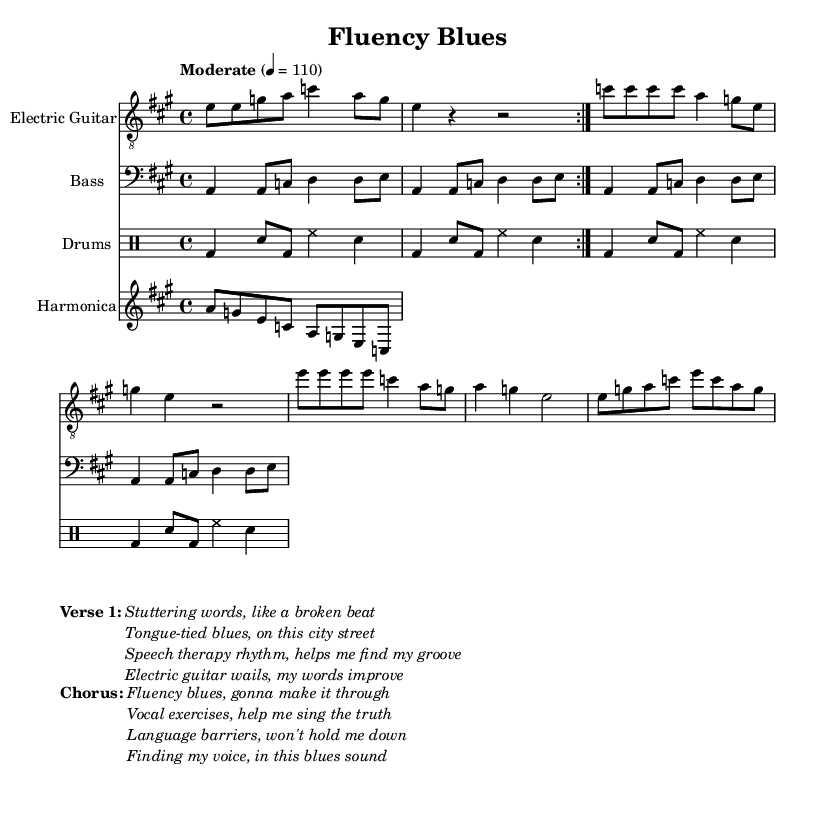What is the key signature of this music? The key signature is A major, which has three sharps (F#, C#, and G#). This can be identified in the left corner of the staff where the sharp symbols are placed.
Answer: A major What is the time signature of this music? The time signature is 4/4, which is indicated by the two numbers at the beginning of the piece, telling us there are four beats per measure.
Answer: 4/4 What is the tempo marking of this piece? The tempo is marked as "Moderate" with a metronome marking of 110 beats per minute. This can be seen at the start where the tempo is indicated.
Answer: Moderate, 110 How many repetitions are there in the intro section? The intro section is marked to repeat twice, as indicated by the "repeat volta 2" notation before the introductory riff.
Answer: 2 What instrument plays the harmonica solo? The score clearly shows that the harmonica solo is written for the "Harmonica" staff, distinguishing it from other instruments in the ensemble.
Answer: Harmonica What are the main themes expressed in the verse section? The verse discusses overcoming speech difficulties and improving fluency through rhythm and music, which can be understood by analyzing the lyrics provided in the markup section.
Answer: Speech therapy and rhythm What specific musical elements are characteristic of Electric Blues in this piece? The piece features a call-and-response structure typical of Electric Blues, with prominent electric guitar riffs, vocal exercises, and lyrical themes surrounding personal struggles related to speech, which are hallmarks of this genre.
Answer: Call-and-response, electric guitar riffs 